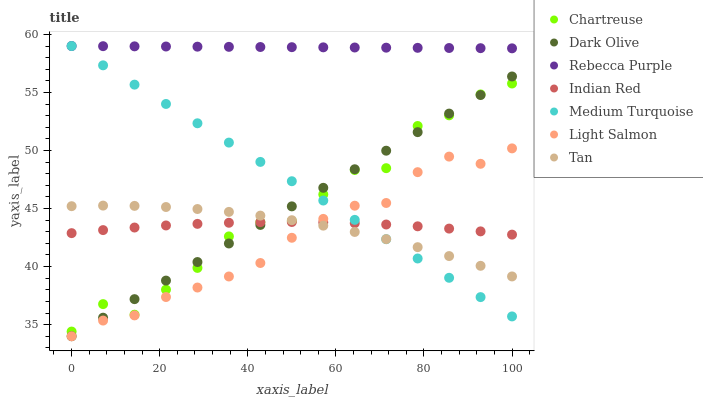Does Light Salmon have the minimum area under the curve?
Answer yes or no. Yes. Does Rebecca Purple have the maximum area under the curve?
Answer yes or no. Yes. Does Medium Turquoise have the minimum area under the curve?
Answer yes or no. No. Does Medium Turquoise have the maximum area under the curve?
Answer yes or no. No. Is Rebecca Purple the smoothest?
Answer yes or no. Yes. Is Chartreuse the roughest?
Answer yes or no. Yes. Is Medium Turquoise the smoothest?
Answer yes or no. No. Is Medium Turquoise the roughest?
Answer yes or no. No. Does Light Salmon have the lowest value?
Answer yes or no. Yes. Does Medium Turquoise have the lowest value?
Answer yes or no. No. Does Rebecca Purple have the highest value?
Answer yes or no. Yes. Does Dark Olive have the highest value?
Answer yes or no. No. Is Indian Red less than Rebecca Purple?
Answer yes or no. Yes. Is Rebecca Purple greater than Dark Olive?
Answer yes or no. Yes. Does Medium Turquoise intersect Tan?
Answer yes or no. Yes. Is Medium Turquoise less than Tan?
Answer yes or no. No. Is Medium Turquoise greater than Tan?
Answer yes or no. No. Does Indian Red intersect Rebecca Purple?
Answer yes or no. No. 